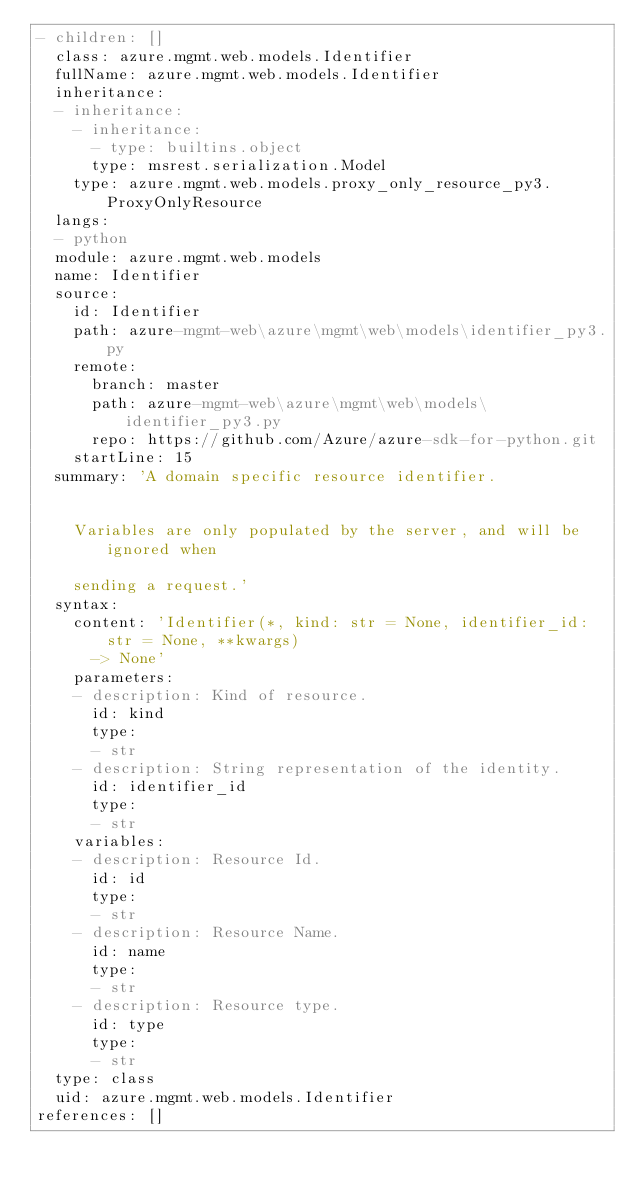Convert code to text. <code><loc_0><loc_0><loc_500><loc_500><_YAML_>- children: []
  class: azure.mgmt.web.models.Identifier
  fullName: azure.mgmt.web.models.Identifier
  inheritance:
  - inheritance:
    - inheritance:
      - type: builtins.object
      type: msrest.serialization.Model
    type: azure.mgmt.web.models.proxy_only_resource_py3.ProxyOnlyResource
  langs:
  - python
  module: azure.mgmt.web.models
  name: Identifier
  source:
    id: Identifier
    path: azure-mgmt-web\azure\mgmt\web\models\identifier_py3.py
    remote:
      branch: master
      path: azure-mgmt-web\azure\mgmt\web\models\identifier_py3.py
      repo: https://github.com/Azure/azure-sdk-for-python.git
    startLine: 15
  summary: 'A domain specific resource identifier.


    Variables are only populated by the server, and will be ignored when

    sending a request.'
  syntax:
    content: 'Identifier(*, kind: str = None, identifier_id: str = None, **kwargs)
      -> None'
    parameters:
    - description: Kind of resource.
      id: kind
      type:
      - str
    - description: String representation of the identity.
      id: identifier_id
      type:
      - str
    variables:
    - description: Resource Id.
      id: id
      type:
      - str
    - description: Resource Name.
      id: name
      type:
      - str
    - description: Resource type.
      id: type
      type:
      - str
  type: class
  uid: azure.mgmt.web.models.Identifier
references: []
</code> 